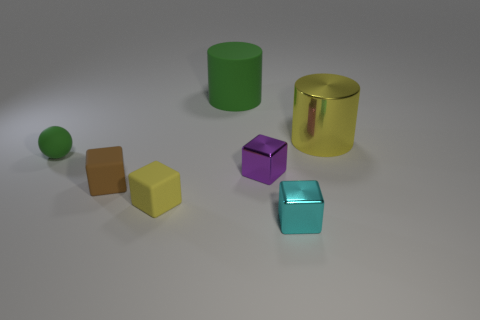Are there any yellow shiny spheres of the same size as the rubber ball?
Your response must be concise. No. Are there an equal number of tiny yellow matte blocks behind the small green object and big cyan shiny spheres?
Give a very brief answer. Yes. The brown matte thing is what size?
Your response must be concise. Small. There is a small cube left of the yellow cube; what number of yellow matte objects are behind it?
Provide a short and direct response. 0. There is a shiny thing that is both right of the purple cube and in front of the yellow metallic cylinder; what is its shape?
Your answer should be very brief. Cube. How many other metal cylinders are the same color as the shiny cylinder?
Provide a succinct answer. 0. Is there a small brown rubber object right of the yellow object on the left side of the green matte object behind the small ball?
Your response must be concise. No. How big is the rubber object that is in front of the yellow cylinder and right of the small brown object?
Ensure brevity in your answer.  Small. What number of brown blocks are the same material as the tiny cyan cube?
Your answer should be compact. 0. What number of spheres are brown matte objects or tiny green things?
Offer a terse response. 1. 